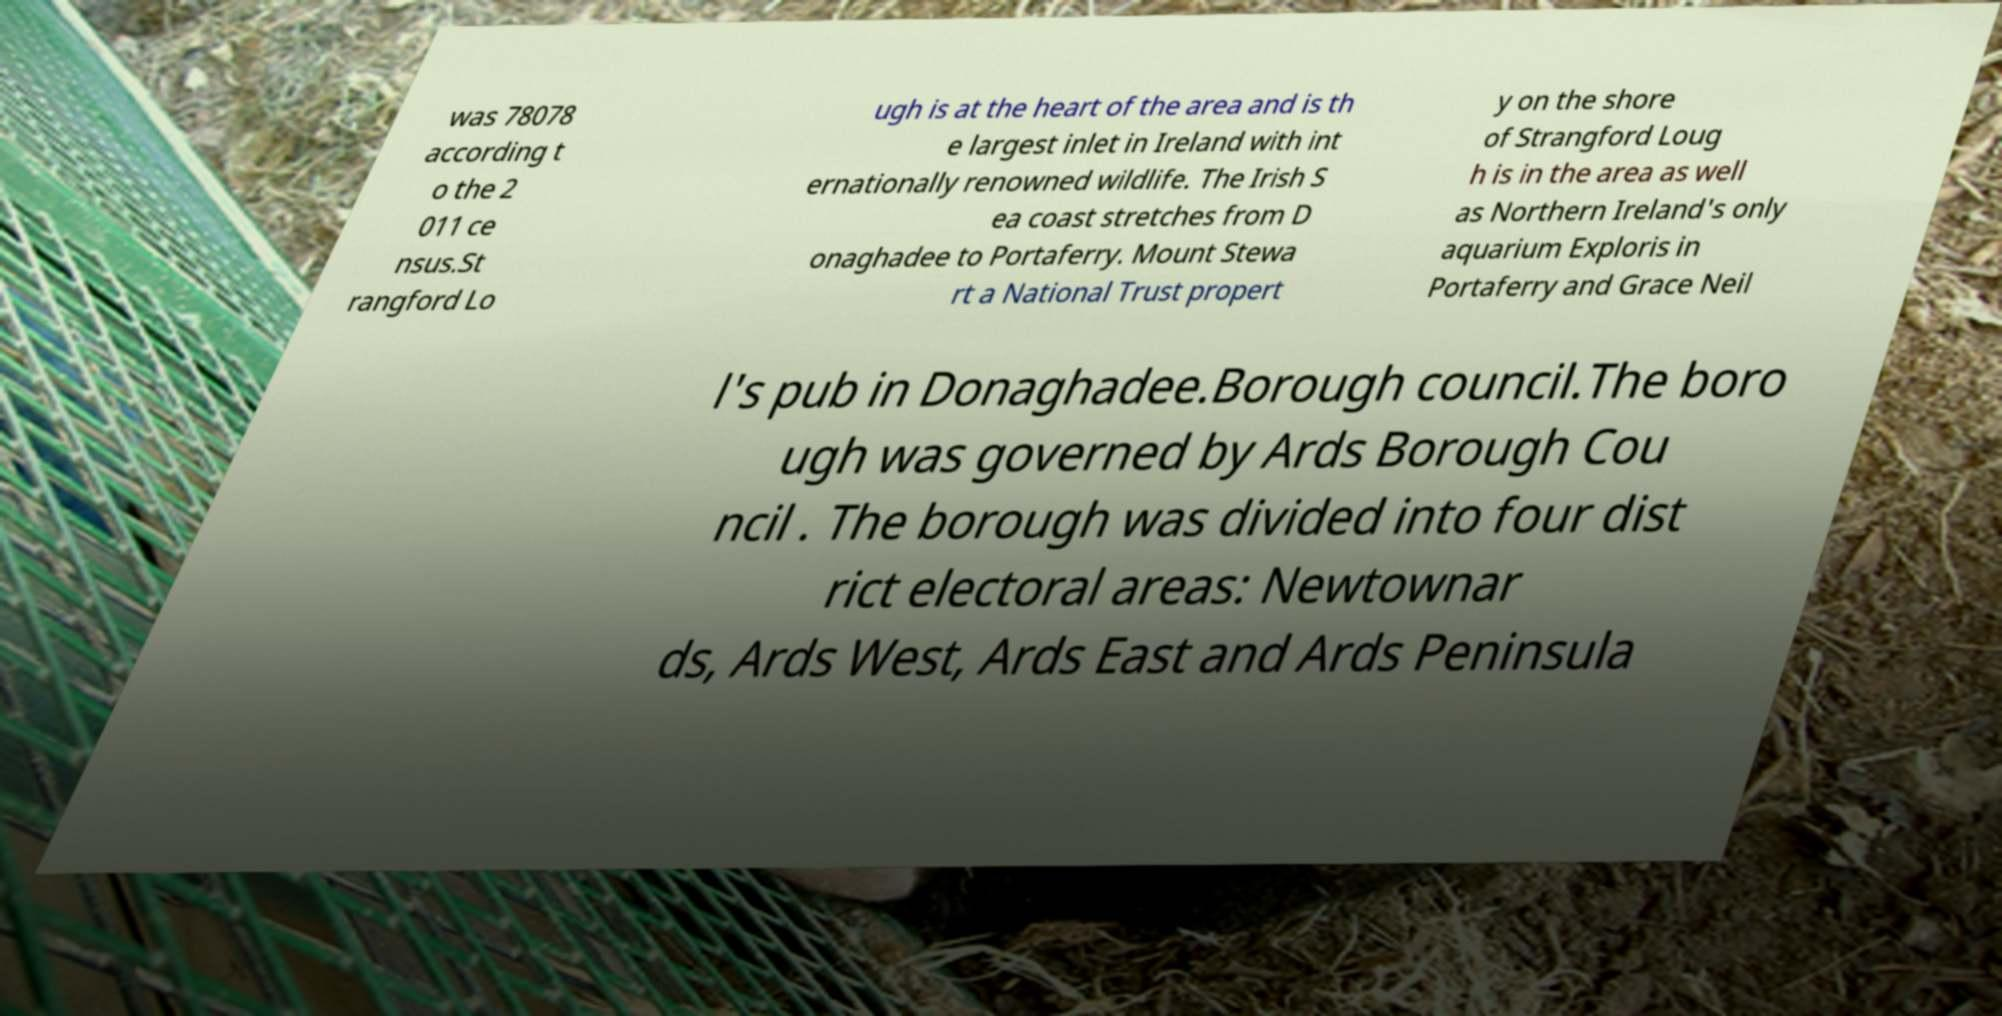What messages or text are displayed in this image? I need them in a readable, typed format. was 78078 according t o the 2 011 ce nsus.St rangford Lo ugh is at the heart of the area and is th e largest inlet in Ireland with int ernationally renowned wildlife. The Irish S ea coast stretches from D onaghadee to Portaferry. Mount Stewa rt a National Trust propert y on the shore of Strangford Loug h is in the area as well as Northern Ireland's only aquarium Exploris in Portaferry and Grace Neil l's pub in Donaghadee.Borough council.The boro ugh was governed by Ards Borough Cou ncil . The borough was divided into four dist rict electoral areas: Newtownar ds, Ards West, Ards East and Ards Peninsula 